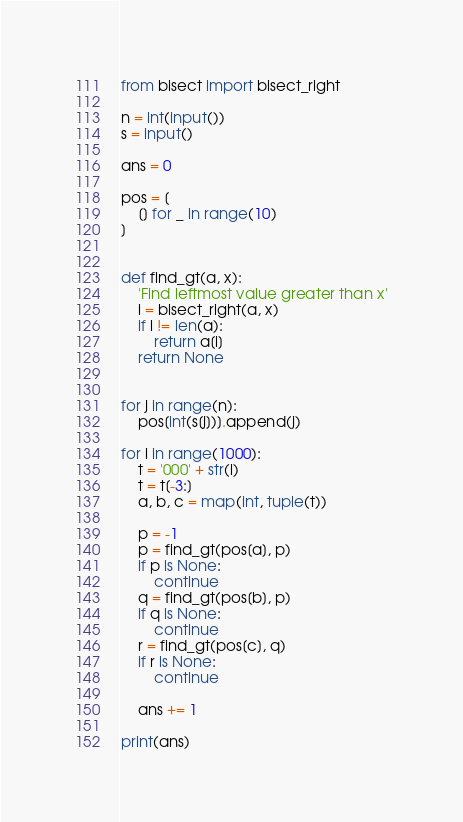Convert code to text. <code><loc_0><loc_0><loc_500><loc_500><_Python_>from bisect import bisect_right

n = int(input())
s = input()

ans = 0

pos = [
    [] for _ in range(10)
]


def find_gt(a, x):
    'Find leftmost value greater than x'
    i = bisect_right(a, x)
    if i != len(a):
        return a[i]
    return None


for j in range(n):
    pos[int(s[j])].append(j)

for i in range(1000):
    t = '000' + str(i)
    t = t[-3:]
    a, b, c = map(int, tuple(t))

    p = -1
    p = find_gt(pos[a], p)
    if p is None:
        continue
    q = find_gt(pos[b], p)
    if q is None:
        continue
    r = find_gt(pos[c], q)
    if r is None:
        continue

    ans += 1

print(ans)
</code> 